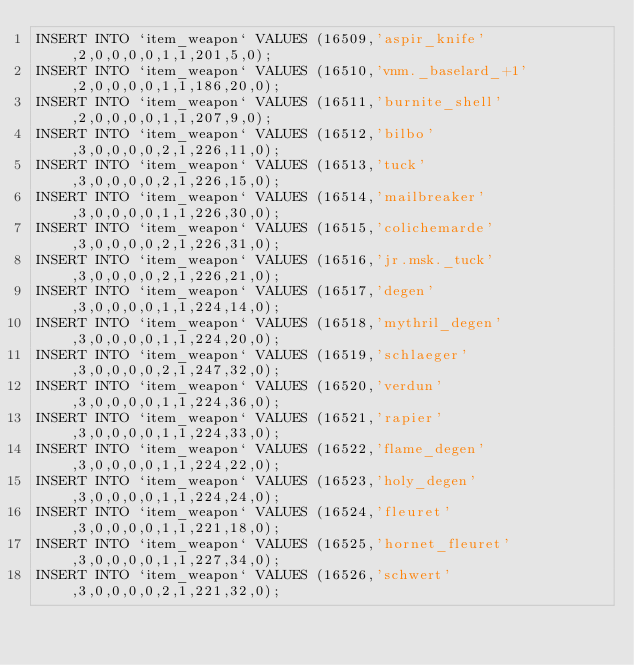Convert code to text. <code><loc_0><loc_0><loc_500><loc_500><_SQL_>INSERT INTO `item_weapon` VALUES (16509,'aspir_knife',2,0,0,0,0,1,1,201,5,0);
INSERT INTO `item_weapon` VALUES (16510,'vnm._baselard_+1',2,0,0,0,0,1,1,186,20,0);
INSERT INTO `item_weapon` VALUES (16511,'burnite_shell',2,0,0,0,0,1,1,207,9,0);
INSERT INTO `item_weapon` VALUES (16512,'bilbo',3,0,0,0,0,2,1,226,11,0);
INSERT INTO `item_weapon` VALUES (16513,'tuck',3,0,0,0,0,2,1,226,15,0);
INSERT INTO `item_weapon` VALUES (16514,'mailbreaker',3,0,0,0,0,1,1,226,30,0);
INSERT INTO `item_weapon` VALUES (16515,'colichemarde',3,0,0,0,0,2,1,226,31,0);
INSERT INTO `item_weapon` VALUES (16516,'jr.msk._tuck',3,0,0,0,0,2,1,226,21,0);
INSERT INTO `item_weapon` VALUES (16517,'degen',3,0,0,0,0,1,1,224,14,0);
INSERT INTO `item_weapon` VALUES (16518,'mythril_degen',3,0,0,0,0,1,1,224,20,0);
INSERT INTO `item_weapon` VALUES (16519,'schlaeger',3,0,0,0,0,2,1,247,32,0);
INSERT INTO `item_weapon` VALUES (16520,'verdun',3,0,0,0,0,1,1,224,36,0);
INSERT INTO `item_weapon` VALUES (16521,'rapier',3,0,0,0,0,1,1,224,33,0);
INSERT INTO `item_weapon` VALUES (16522,'flame_degen',3,0,0,0,0,1,1,224,22,0);
INSERT INTO `item_weapon` VALUES (16523,'holy_degen',3,0,0,0,0,1,1,224,24,0);
INSERT INTO `item_weapon` VALUES (16524,'fleuret',3,0,0,0,0,1,1,221,18,0);
INSERT INTO `item_weapon` VALUES (16525,'hornet_fleuret',3,0,0,0,0,1,1,227,34,0);
INSERT INTO `item_weapon` VALUES (16526,'schwert',3,0,0,0,0,2,1,221,32,0);</code> 